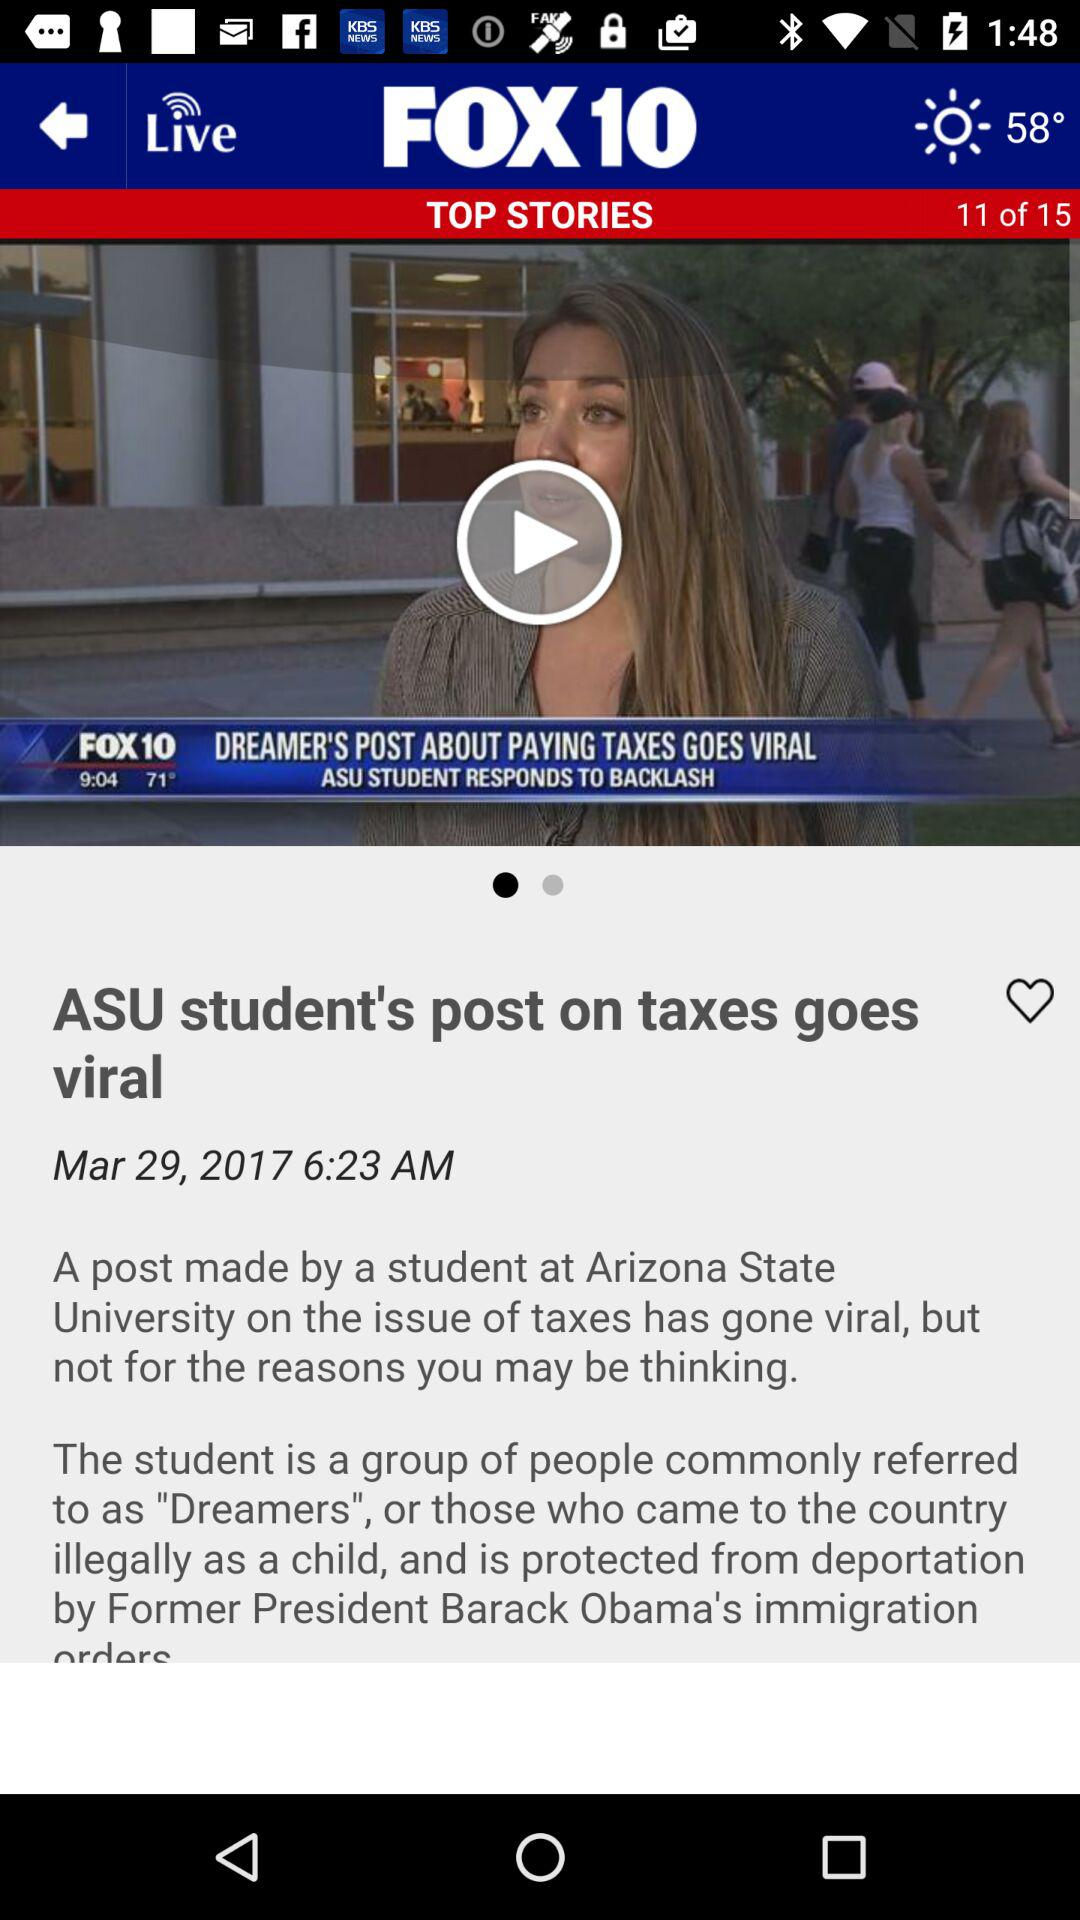On what date was the article published? The article was published on March 29, 2017. 